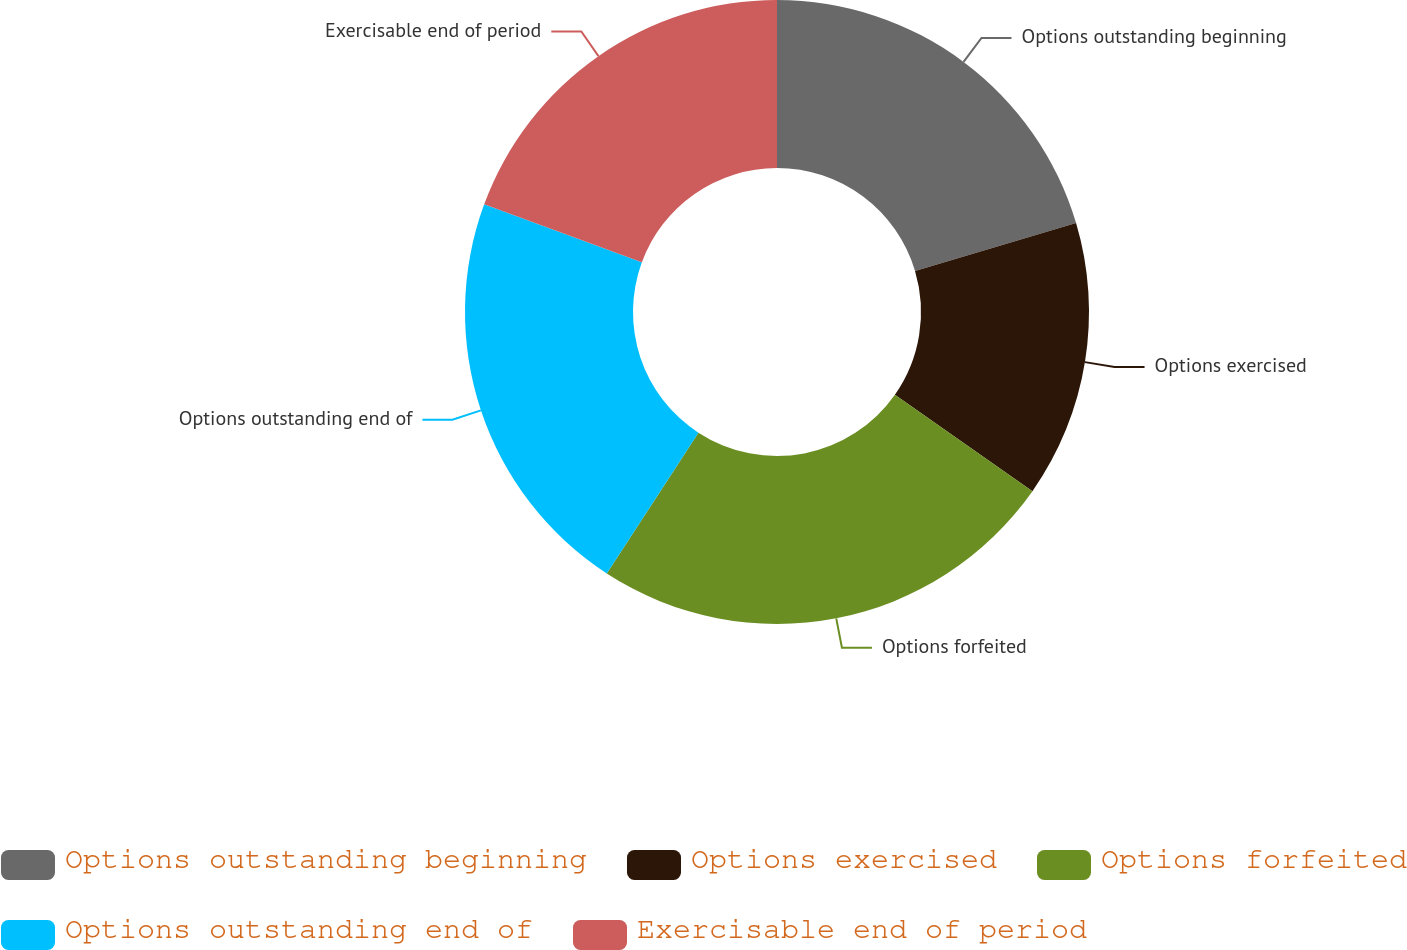Convert chart. <chart><loc_0><loc_0><loc_500><loc_500><pie_chart><fcel>Options outstanding beginning<fcel>Options exercised<fcel>Options forfeited<fcel>Options outstanding end of<fcel>Exercisable end of period<nl><fcel>20.4%<fcel>14.33%<fcel>24.45%<fcel>21.42%<fcel>19.39%<nl></chart> 